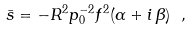Convert formula to latex. <formula><loc_0><loc_0><loc_500><loc_500>\bar { s } = - R ^ { 2 } p _ { 0 } ^ { - 2 } f ^ { 2 } ( \alpha + i \, \beta ) \ ,</formula> 